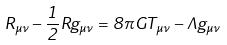<formula> <loc_0><loc_0><loc_500><loc_500>R _ { \mu \nu } - \frac { 1 } { 2 } R g _ { \mu \nu } = 8 \pi G T _ { \mu \nu } - \Lambda g _ { \mu \nu }</formula> 